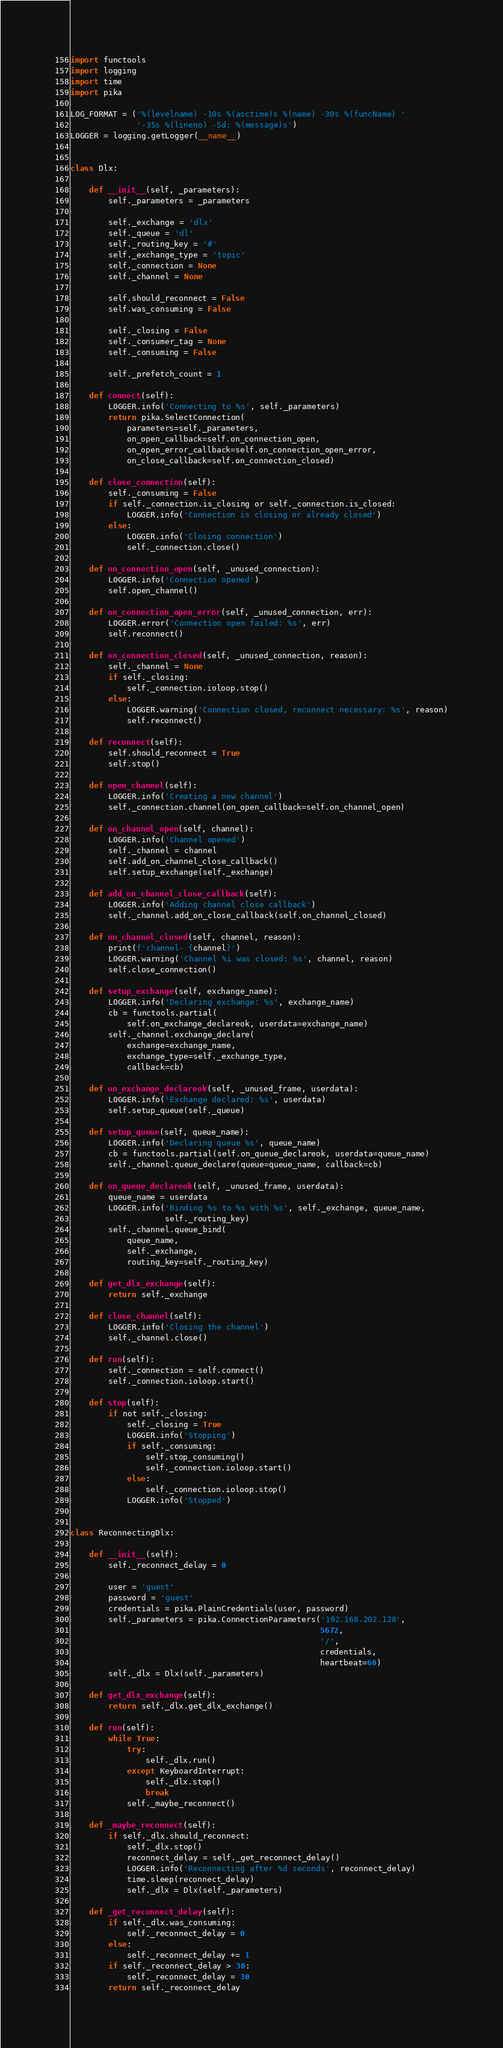Convert code to text. <code><loc_0><loc_0><loc_500><loc_500><_Python_>import functools
import logging
import time
import pika

LOG_FORMAT = ('%(levelname) -10s %(asctime)s %(name) -30s %(funcName) '
              '-35s %(lineno) -5d: %(message)s')
LOGGER = logging.getLogger(__name__)


class Dlx:

    def __init__(self, _parameters):
        self._parameters = _parameters

        self._exchange = 'dlx'
        self._queue = 'dl'
        self._routing_key = '#'
        self._exchange_type = 'topic'
        self._connection = None
        self._channel = None

        self.should_reconnect = False
        self.was_consuming = False

        self._closing = False
        self._consumer_tag = None
        self._consuming = False

        self._prefetch_count = 1

    def connect(self):
        LOGGER.info('Connecting to %s', self._parameters)
        return pika.SelectConnection(
            parameters=self._parameters,
            on_open_callback=self.on_connection_open,
            on_open_error_callback=self.on_connection_open_error,
            on_close_callback=self.on_connection_closed)

    def close_connection(self):
        self._consuming = False
        if self._connection.is_closing or self._connection.is_closed:
            LOGGER.info('Connection is closing or already closed')
        else:
            LOGGER.info('Closing connection')
            self._connection.close()

    def on_connection_open(self, _unused_connection):
        LOGGER.info('Connection opened')
        self.open_channel()

    def on_connection_open_error(self, _unused_connection, err):
        LOGGER.error('Connection open failed: %s', err)
        self.reconnect()

    def on_connection_closed(self, _unused_connection, reason):
        self._channel = None
        if self._closing:
            self._connection.ioloop.stop()
        else:
            LOGGER.warning('Connection closed, reconnect necessary: %s', reason)
            self.reconnect()

    def reconnect(self):
        self.should_reconnect = True
        self.stop()

    def open_channel(self):
        LOGGER.info('Creating a new channel')
        self._connection.channel(on_open_callback=self.on_channel_open)

    def on_channel_open(self, channel):
        LOGGER.info('Channel opened')
        self._channel = channel
        self.add_on_channel_close_callback()
        self.setup_exchange(self._exchange)

    def add_on_channel_close_callback(self):
        LOGGER.info('Adding channel close callback')
        self._channel.add_on_close_callback(self.on_channel_closed)

    def on_channel_closed(self, channel, reason):
        print(f'channel- {channel}')
        LOGGER.warning('Channel %i was closed: %s', channel, reason)
        self.close_connection()

    def setup_exchange(self, exchange_name):
        LOGGER.info('Declaring exchange: %s', exchange_name)
        cb = functools.partial(
            self.on_exchange_declareok, userdata=exchange_name)
        self._channel.exchange_declare(
            exchange=exchange_name,
            exchange_type=self._exchange_type,
            callback=cb)

    def on_exchange_declareok(self, _unused_frame, userdata):
        LOGGER.info('Exchange declared: %s', userdata)
        self.setup_queue(self._queue)

    def setup_queue(self, queue_name):
        LOGGER.info('Declaring queue %s', queue_name)
        cb = functools.partial(self.on_queue_declareok, userdata=queue_name)
        self._channel.queue_declare(queue=queue_name, callback=cb)

    def on_queue_declareok(self, _unused_frame, userdata):
        queue_name = userdata
        LOGGER.info('Binding %s to %s with %s', self._exchange, queue_name,
                    self._routing_key)
        self._channel.queue_bind(
            queue_name,
            self._exchange,
            routing_key=self._routing_key)

    def get_dlx_exchange(self):
        return self._exchange

    def close_channel(self):
        LOGGER.info('Closing the channel')
        self._channel.close()

    def run(self):
        self._connection = self.connect()
        self._connection.ioloop.start()

    def stop(self):
        if not self._closing:
            self._closing = True
            LOGGER.info('Stopping')
            if self._consuming:
                self.stop_consuming()
                self._connection.ioloop.start()
            else:
                self._connection.ioloop.stop()
            LOGGER.info('Stopped')


class ReconnectingDlx:

    def __init__(self):
        self._reconnect_delay = 0

        user = 'guest'
        password = 'guest'
        credentials = pika.PlainCredentials(user, password)
        self._parameters = pika.ConnectionParameters('192.168.202.128',
                                                     5672,
                                                     '/',
                                                     credentials,
                                                     heartbeat=60)
        self._dlx = Dlx(self._parameters)

    def get_dlx_exchange(self):
        return self._dlx.get_dlx_exchange()

    def run(self):
        while True:
            try:
                self._dlx.run()
            except KeyboardInterrupt:
                self._dlx.stop()
                break
            self._maybe_reconnect()

    def _maybe_reconnect(self):
        if self._dlx.should_reconnect:
            self._dlx.stop()
            reconnect_delay = self._get_reconnect_delay()
            LOGGER.info('Reconnecting after %d seconds', reconnect_delay)
            time.sleep(reconnect_delay)
            self._dlx = Dlx(self._parameters)

    def _get_reconnect_delay(self):
        if self._dlx.was_consuming:
            self._reconnect_delay = 0
        else:
            self._reconnect_delay += 1
        if self._reconnect_delay > 30:
            self._reconnect_delay = 30
        return self._reconnect_delay
</code> 